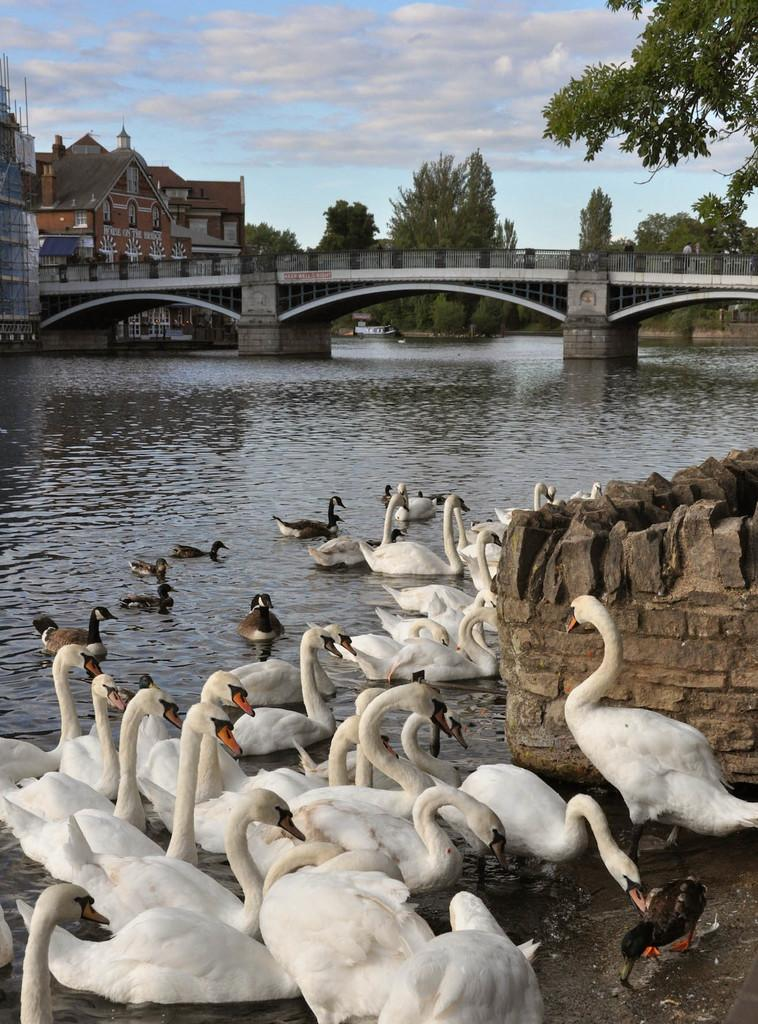What animals can be seen in the image? There are swans in the image. What is the primary element in which the swans are situated? There is water in the image, and the swans are in it. What type of structure is present in the image? There is a bridge in the image. What else can be seen in the image besides the swans and the bridge? There are buildings, trees, and the sky visible in the image. What is the condition of the sky in the image? The sky is visible in the background of the image, and there are clouds in it. Can you see any fairies flying around the swans in the image? No, there are no fairies present in the image. What type of cart can be seen carrying copper in the image? There is no cart or copper present in the image. 